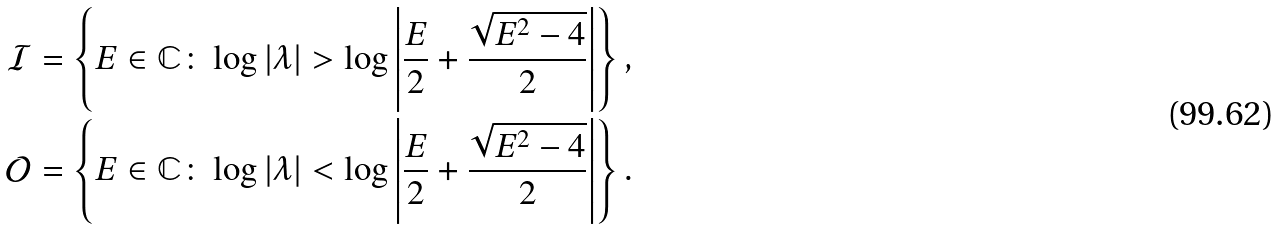Convert formula to latex. <formula><loc_0><loc_0><loc_500><loc_500>\mathcal { I } & = \left \{ E \in \mathbb { C } \colon \log | \lambda | > \log \left | \frac { E } { 2 } + \frac { \sqrt { E ^ { 2 } - 4 } } { 2 } \right | \right \} , \\ \mathcal { O } & = \left \{ E \in \mathbb { C } \colon \log | \lambda | < \log \left | \frac { E } { 2 } + \frac { \sqrt { E ^ { 2 } - 4 } } { 2 } \right | \right \} .</formula> 